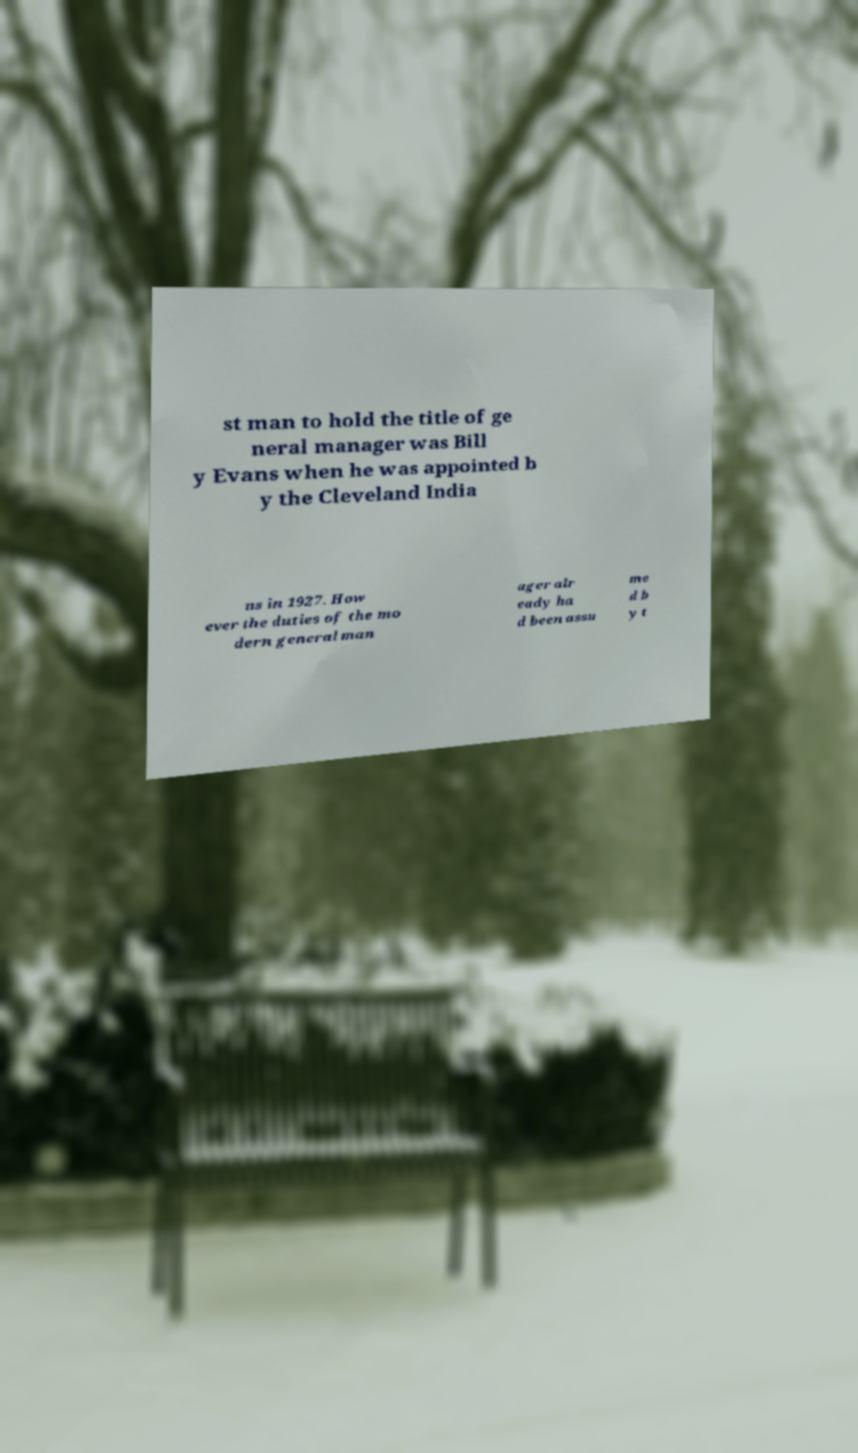Could you assist in decoding the text presented in this image and type it out clearly? st man to hold the title of ge neral manager was Bill y Evans when he was appointed b y the Cleveland India ns in 1927. How ever the duties of the mo dern general man ager alr eady ha d been assu me d b y t 